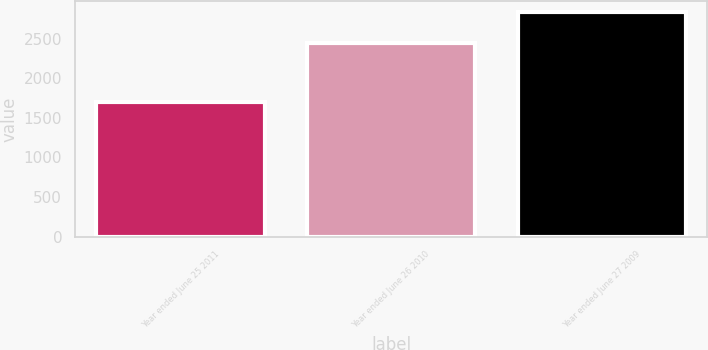<chart> <loc_0><loc_0><loc_500><loc_500><bar_chart><fcel>Year ended June 25 2011<fcel>Year ended June 26 2010<fcel>Year ended June 27 2009<nl><fcel>1705<fcel>2446<fcel>2831<nl></chart> 